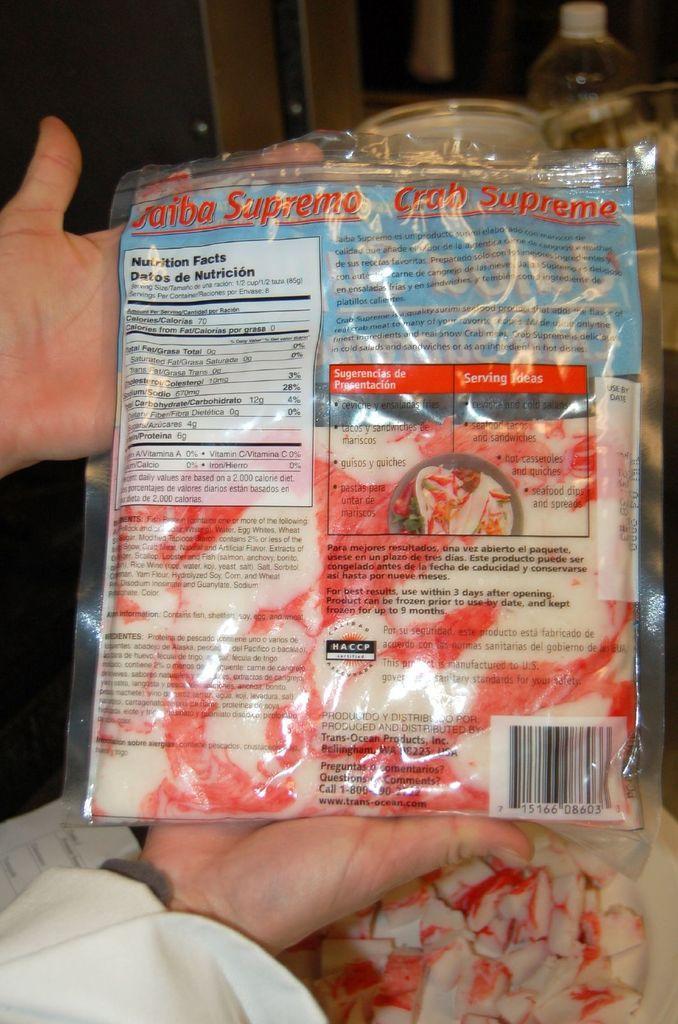Please provide a concise description of this image. In this image, we can see a person holding a crab supreme packet and in the background, there is a bottle and we can see some other objects. At the bottom, we can see crab supreme flakes on the plate. 